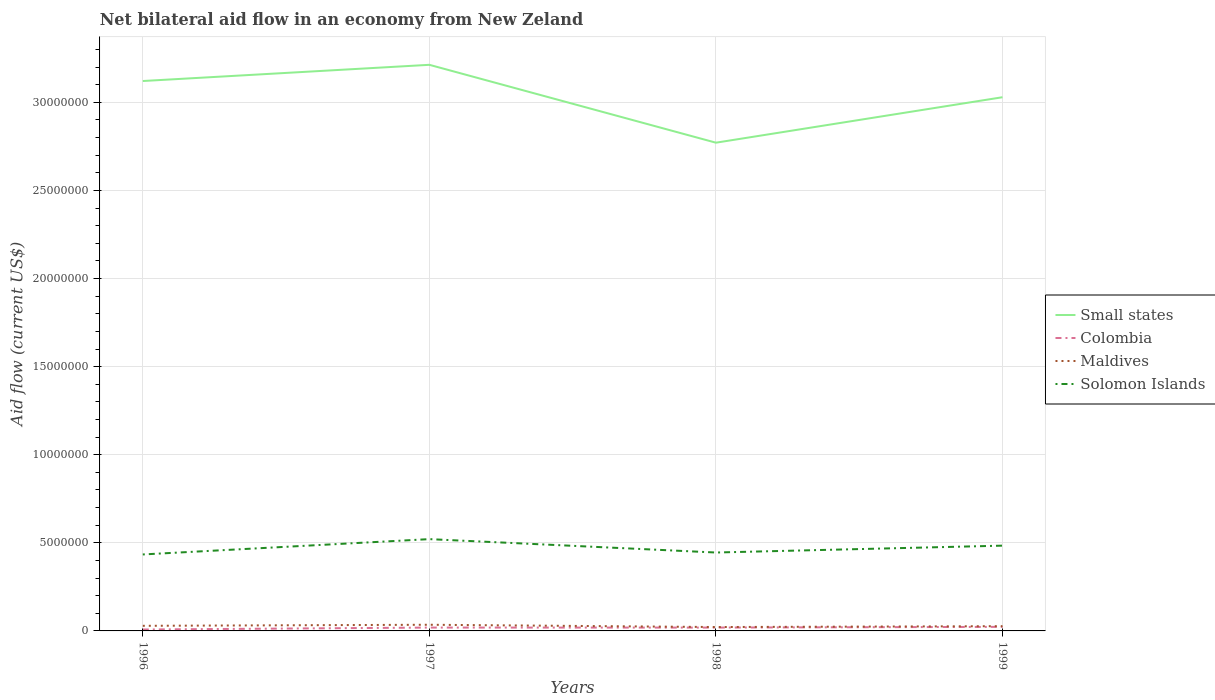Is the number of lines equal to the number of legend labels?
Ensure brevity in your answer.  Yes. Across all years, what is the maximum net bilateral aid flow in Solomon Islands?
Provide a short and direct response. 4.34e+06. What is the total net bilateral aid flow in Solomon Islands in the graph?
Your response must be concise. -8.70e+05. What is the difference between the highest and the lowest net bilateral aid flow in Solomon Islands?
Your answer should be very brief. 2. How many lines are there?
Offer a terse response. 4. How many years are there in the graph?
Your answer should be very brief. 4. What is the difference between two consecutive major ticks on the Y-axis?
Make the answer very short. 5.00e+06. Does the graph contain any zero values?
Your answer should be very brief. No. Where does the legend appear in the graph?
Provide a short and direct response. Center right. How many legend labels are there?
Your answer should be very brief. 4. How are the legend labels stacked?
Provide a succinct answer. Vertical. What is the title of the graph?
Your answer should be compact. Net bilateral aid flow in an economy from New Zeland. What is the label or title of the X-axis?
Your answer should be compact. Years. What is the Aid flow (current US$) of Small states in 1996?
Give a very brief answer. 3.12e+07. What is the Aid flow (current US$) in Colombia in 1996?
Give a very brief answer. 8.00e+04. What is the Aid flow (current US$) of Maldives in 1996?
Your answer should be compact. 2.90e+05. What is the Aid flow (current US$) of Solomon Islands in 1996?
Your response must be concise. 4.34e+06. What is the Aid flow (current US$) in Small states in 1997?
Your answer should be compact. 3.21e+07. What is the Aid flow (current US$) of Solomon Islands in 1997?
Make the answer very short. 5.21e+06. What is the Aid flow (current US$) of Small states in 1998?
Your answer should be compact. 2.77e+07. What is the Aid flow (current US$) of Colombia in 1998?
Give a very brief answer. 1.90e+05. What is the Aid flow (current US$) in Solomon Islands in 1998?
Make the answer very short. 4.45e+06. What is the Aid flow (current US$) in Small states in 1999?
Offer a terse response. 3.03e+07. What is the Aid flow (current US$) in Colombia in 1999?
Offer a terse response. 2.30e+05. What is the Aid flow (current US$) of Maldives in 1999?
Keep it short and to the point. 2.70e+05. What is the Aid flow (current US$) of Solomon Islands in 1999?
Your response must be concise. 4.84e+06. Across all years, what is the maximum Aid flow (current US$) of Small states?
Your response must be concise. 3.21e+07. Across all years, what is the maximum Aid flow (current US$) of Colombia?
Make the answer very short. 2.30e+05. Across all years, what is the maximum Aid flow (current US$) in Maldives?
Provide a succinct answer. 3.50e+05. Across all years, what is the maximum Aid flow (current US$) in Solomon Islands?
Offer a very short reply. 5.21e+06. Across all years, what is the minimum Aid flow (current US$) in Small states?
Offer a terse response. 2.77e+07. Across all years, what is the minimum Aid flow (current US$) in Maldives?
Offer a terse response. 2.20e+05. Across all years, what is the minimum Aid flow (current US$) of Solomon Islands?
Keep it short and to the point. 4.34e+06. What is the total Aid flow (current US$) in Small states in the graph?
Provide a short and direct response. 1.21e+08. What is the total Aid flow (current US$) of Colombia in the graph?
Give a very brief answer. 6.90e+05. What is the total Aid flow (current US$) of Maldives in the graph?
Provide a succinct answer. 1.13e+06. What is the total Aid flow (current US$) of Solomon Islands in the graph?
Keep it short and to the point. 1.88e+07. What is the difference between the Aid flow (current US$) in Small states in 1996 and that in 1997?
Give a very brief answer. -9.20e+05. What is the difference between the Aid flow (current US$) of Colombia in 1996 and that in 1997?
Your answer should be compact. -1.10e+05. What is the difference between the Aid flow (current US$) in Solomon Islands in 1996 and that in 1997?
Your answer should be very brief. -8.70e+05. What is the difference between the Aid flow (current US$) in Small states in 1996 and that in 1998?
Offer a terse response. 3.50e+06. What is the difference between the Aid flow (current US$) in Maldives in 1996 and that in 1998?
Provide a short and direct response. 7.00e+04. What is the difference between the Aid flow (current US$) of Small states in 1996 and that in 1999?
Keep it short and to the point. 9.20e+05. What is the difference between the Aid flow (current US$) in Maldives in 1996 and that in 1999?
Make the answer very short. 2.00e+04. What is the difference between the Aid flow (current US$) of Solomon Islands in 1996 and that in 1999?
Keep it short and to the point. -5.00e+05. What is the difference between the Aid flow (current US$) of Small states in 1997 and that in 1998?
Your answer should be compact. 4.42e+06. What is the difference between the Aid flow (current US$) in Colombia in 1997 and that in 1998?
Your response must be concise. 0. What is the difference between the Aid flow (current US$) of Maldives in 1997 and that in 1998?
Your answer should be very brief. 1.30e+05. What is the difference between the Aid flow (current US$) in Solomon Islands in 1997 and that in 1998?
Offer a terse response. 7.60e+05. What is the difference between the Aid flow (current US$) of Small states in 1997 and that in 1999?
Your answer should be compact. 1.84e+06. What is the difference between the Aid flow (current US$) in Small states in 1998 and that in 1999?
Offer a very short reply. -2.58e+06. What is the difference between the Aid flow (current US$) of Solomon Islands in 1998 and that in 1999?
Provide a succinct answer. -3.90e+05. What is the difference between the Aid flow (current US$) in Small states in 1996 and the Aid flow (current US$) in Colombia in 1997?
Ensure brevity in your answer.  3.10e+07. What is the difference between the Aid flow (current US$) of Small states in 1996 and the Aid flow (current US$) of Maldives in 1997?
Give a very brief answer. 3.09e+07. What is the difference between the Aid flow (current US$) in Small states in 1996 and the Aid flow (current US$) in Solomon Islands in 1997?
Make the answer very short. 2.60e+07. What is the difference between the Aid flow (current US$) in Colombia in 1996 and the Aid flow (current US$) in Maldives in 1997?
Give a very brief answer. -2.70e+05. What is the difference between the Aid flow (current US$) in Colombia in 1996 and the Aid flow (current US$) in Solomon Islands in 1997?
Keep it short and to the point. -5.13e+06. What is the difference between the Aid flow (current US$) in Maldives in 1996 and the Aid flow (current US$) in Solomon Islands in 1997?
Offer a terse response. -4.92e+06. What is the difference between the Aid flow (current US$) in Small states in 1996 and the Aid flow (current US$) in Colombia in 1998?
Offer a very short reply. 3.10e+07. What is the difference between the Aid flow (current US$) in Small states in 1996 and the Aid flow (current US$) in Maldives in 1998?
Ensure brevity in your answer.  3.10e+07. What is the difference between the Aid flow (current US$) in Small states in 1996 and the Aid flow (current US$) in Solomon Islands in 1998?
Keep it short and to the point. 2.68e+07. What is the difference between the Aid flow (current US$) of Colombia in 1996 and the Aid flow (current US$) of Maldives in 1998?
Ensure brevity in your answer.  -1.40e+05. What is the difference between the Aid flow (current US$) in Colombia in 1996 and the Aid flow (current US$) in Solomon Islands in 1998?
Offer a very short reply. -4.37e+06. What is the difference between the Aid flow (current US$) in Maldives in 1996 and the Aid flow (current US$) in Solomon Islands in 1998?
Offer a very short reply. -4.16e+06. What is the difference between the Aid flow (current US$) of Small states in 1996 and the Aid flow (current US$) of Colombia in 1999?
Your answer should be compact. 3.10e+07. What is the difference between the Aid flow (current US$) in Small states in 1996 and the Aid flow (current US$) in Maldives in 1999?
Offer a very short reply. 3.09e+07. What is the difference between the Aid flow (current US$) of Small states in 1996 and the Aid flow (current US$) of Solomon Islands in 1999?
Provide a short and direct response. 2.64e+07. What is the difference between the Aid flow (current US$) of Colombia in 1996 and the Aid flow (current US$) of Solomon Islands in 1999?
Provide a short and direct response. -4.76e+06. What is the difference between the Aid flow (current US$) in Maldives in 1996 and the Aid flow (current US$) in Solomon Islands in 1999?
Offer a terse response. -4.55e+06. What is the difference between the Aid flow (current US$) of Small states in 1997 and the Aid flow (current US$) of Colombia in 1998?
Offer a terse response. 3.19e+07. What is the difference between the Aid flow (current US$) of Small states in 1997 and the Aid flow (current US$) of Maldives in 1998?
Offer a terse response. 3.19e+07. What is the difference between the Aid flow (current US$) of Small states in 1997 and the Aid flow (current US$) of Solomon Islands in 1998?
Offer a very short reply. 2.77e+07. What is the difference between the Aid flow (current US$) of Colombia in 1997 and the Aid flow (current US$) of Maldives in 1998?
Keep it short and to the point. -3.00e+04. What is the difference between the Aid flow (current US$) of Colombia in 1997 and the Aid flow (current US$) of Solomon Islands in 1998?
Make the answer very short. -4.26e+06. What is the difference between the Aid flow (current US$) in Maldives in 1997 and the Aid flow (current US$) in Solomon Islands in 1998?
Make the answer very short. -4.10e+06. What is the difference between the Aid flow (current US$) in Small states in 1997 and the Aid flow (current US$) in Colombia in 1999?
Offer a terse response. 3.19e+07. What is the difference between the Aid flow (current US$) in Small states in 1997 and the Aid flow (current US$) in Maldives in 1999?
Make the answer very short. 3.19e+07. What is the difference between the Aid flow (current US$) of Small states in 1997 and the Aid flow (current US$) of Solomon Islands in 1999?
Provide a short and direct response. 2.73e+07. What is the difference between the Aid flow (current US$) of Colombia in 1997 and the Aid flow (current US$) of Maldives in 1999?
Ensure brevity in your answer.  -8.00e+04. What is the difference between the Aid flow (current US$) in Colombia in 1997 and the Aid flow (current US$) in Solomon Islands in 1999?
Provide a short and direct response. -4.65e+06. What is the difference between the Aid flow (current US$) of Maldives in 1997 and the Aid flow (current US$) of Solomon Islands in 1999?
Offer a terse response. -4.49e+06. What is the difference between the Aid flow (current US$) in Small states in 1998 and the Aid flow (current US$) in Colombia in 1999?
Give a very brief answer. 2.75e+07. What is the difference between the Aid flow (current US$) of Small states in 1998 and the Aid flow (current US$) of Maldives in 1999?
Your answer should be compact. 2.74e+07. What is the difference between the Aid flow (current US$) of Small states in 1998 and the Aid flow (current US$) of Solomon Islands in 1999?
Offer a very short reply. 2.29e+07. What is the difference between the Aid flow (current US$) in Colombia in 1998 and the Aid flow (current US$) in Maldives in 1999?
Your answer should be very brief. -8.00e+04. What is the difference between the Aid flow (current US$) of Colombia in 1998 and the Aid flow (current US$) of Solomon Islands in 1999?
Provide a short and direct response. -4.65e+06. What is the difference between the Aid flow (current US$) of Maldives in 1998 and the Aid flow (current US$) of Solomon Islands in 1999?
Provide a succinct answer. -4.62e+06. What is the average Aid flow (current US$) of Small states per year?
Give a very brief answer. 3.03e+07. What is the average Aid flow (current US$) of Colombia per year?
Provide a succinct answer. 1.72e+05. What is the average Aid flow (current US$) in Maldives per year?
Keep it short and to the point. 2.82e+05. What is the average Aid flow (current US$) of Solomon Islands per year?
Ensure brevity in your answer.  4.71e+06. In the year 1996, what is the difference between the Aid flow (current US$) in Small states and Aid flow (current US$) in Colombia?
Your answer should be compact. 3.11e+07. In the year 1996, what is the difference between the Aid flow (current US$) in Small states and Aid flow (current US$) in Maldives?
Your answer should be very brief. 3.09e+07. In the year 1996, what is the difference between the Aid flow (current US$) in Small states and Aid flow (current US$) in Solomon Islands?
Ensure brevity in your answer.  2.69e+07. In the year 1996, what is the difference between the Aid flow (current US$) in Colombia and Aid flow (current US$) in Maldives?
Give a very brief answer. -2.10e+05. In the year 1996, what is the difference between the Aid flow (current US$) in Colombia and Aid flow (current US$) in Solomon Islands?
Offer a very short reply. -4.26e+06. In the year 1996, what is the difference between the Aid flow (current US$) of Maldives and Aid flow (current US$) of Solomon Islands?
Offer a very short reply. -4.05e+06. In the year 1997, what is the difference between the Aid flow (current US$) of Small states and Aid flow (current US$) of Colombia?
Give a very brief answer. 3.19e+07. In the year 1997, what is the difference between the Aid flow (current US$) of Small states and Aid flow (current US$) of Maldives?
Ensure brevity in your answer.  3.18e+07. In the year 1997, what is the difference between the Aid flow (current US$) of Small states and Aid flow (current US$) of Solomon Islands?
Your answer should be compact. 2.69e+07. In the year 1997, what is the difference between the Aid flow (current US$) of Colombia and Aid flow (current US$) of Solomon Islands?
Keep it short and to the point. -5.02e+06. In the year 1997, what is the difference between the Aid flow (current US$) in Maldives and Aid flow (current US$) in Solomon Islands?
Provide a short and direct response. -4.86e+06. In the year 1998, what is the difference between the Aid flow (current US$) of Small states and Aid flow (current US$) of Colombia?
Provide a short and direct response. 2.75e+07. In the year 1998, what is the difference between the Aid flow (current US$) of Small states and Aid flow (current US$) of Maldives?
Provide a succinct answer. 2.75e+07. In the year 1998, what is the difference between the Aid flow (current US$) of Small states and Aid flow (current US$) of Solomon Islands?
Make the answer very short. 2.33e+07. In the year 1998, what is the difference between the Aid flow (current US$) of Colombia and Aid flow (current US$) of Maldives?
Offer a terse response. -3.00e+04. In the year 1998, what is the difference between the Aid flow (current US$) in Colombia and Aid flow (current US$) in Solomon Islands?
Your answer should be very brief. -4.26e+06. In the year 1998, what is the difference between the Aid flow (current US$) of Maldives and Aid flow (current US$) of Solomon Islands?
Offer a very short reply. -4.23e+06. In the year 1999, what is the difference between the Aid flow (current US$) in Small states and Aid flow (current US$) in Colombia?
Give a very brief answer. 3.01e+07. In the year 1999, what is the difference between the Aid flow (current US$) in Small states and Aid flow (current US$) in Maldives?
Keep it short and to the point. 3.00e+07. In the year 1999, what is the difference between the Aid flow (current US$) in Small states and Aid flow (current US$) in Solomon Islands?
Offer a very short reply. 2.54e+07. In the year 1999, what is the difference between the Aid flow (current US$) of Colombia and Aid flow (current US$) of Solomon Islands?
Offer a very short reply. -4.61e+06. In the year 1999, what is the difference between the Aid flow (current US$) of Maldives and Aid flow (current US$) of Solomon Islands?
Give a very brief answer. -4.57e+06. What is the ratio of the Aid flow (current US$) in Small states in 1996 to that in 1997?
Ensure brevity in your answer.  0.97. What is the ratio of the Aid flow (current US$) of Colombia in 1996 to that in 1997?
Make the answer very short. 0.42. What is the ratio of the Aid flow (current US$) of Maldives in 1996 to that in 1997?
Offer a very short reply. 0.83. What is the ratio of the Aid flow (current US$) in Solomon Islands in 1996 to that in 1997?
Ensure brevity in your answer.  0.83. What is the ratio of the Aid flow (current US$) of Small states in 1996 to that in 1998?
Provide a short and direct response. 1.13. What is the ratio of the Aid flow (current US$) of Colombia in 1996 to that in 1998?
Provide a short and direct response. 0.42. What is the ratio of the Aid flow (current US$) in Maldives in 1996 to that in 1998?
Keep it short and to the point. 1.32. What is the ratio of the Aid flow (current US$) of Solomon Islands in 1996 to that in 1998?
Give a very brief answer. 0.98. What is the ratio of the Aid flow (current US$) of Small states in 1996 to that in 1999?
Your answer should be very brief. 1.03. What is the ratio of the Aid flow (current US$) in Colombia in 1996 to that in 1999?
Ensure brevity in your answer.  0.35. What is the ratio of the Aid flow (current US$) in Maldives in 1996 to that in 1999?
Offer a very short reply. 1.07. What is the ratio of the Aid flow (current US$) of Solomon Islands in 1996 to that in 1999?
Your answer should be compact. 0.9. What is the ratio of the Aid flow (current US$) in Small states in 1997 to that in 1998?
Make the answer very short. 1.16. What is the ratio of the Aid flow (current US$) of Colombia in 1997 to that in 1998?
Make the answer very short. 1. What is the ratio of the Aid flow (current US$) of Maldives in 1997 to that in 1998?
Your response must be concise. 1.59. What is the ratio of the Aid flow (current US$) in Solomon Islands in 1997 to that in 1998?
Your answer should be very brief. 1.17. What is the ratio of the Aid flow (current US$) in Small states in 1997 to that in 1999?
Give a very brief answer. 1.06. What is the ratio of the Aid flow (current US$) of Colombia in 1997 to that in 1999?
Keep it short and to the point. 0.83. What is the ratio of the Aid flow (current US$) of Maldives in 1997 to that in 1999?
Offer a terse response. 1.3. What is the ratio of the Aid flow (current US$) in Solomon Islands in 1997 to that in 1999?
Your answer should be very brief. 1.08. What is the ratio of the Aid flow (current US$) in Small states in 1998 to that in 1999?
Provide a succinct answer. 0.91. What is the ratio of the Aid flow (current US$) in Colombia in 1998 to that in 1999?
Your answer should be very brief. 0.83. What is the ratio of the Aid flow (current US$) in Maldives in 1998 to that in 1999?
Your answer should be very brief. 0.81. What is the ratio of the Aid flow (current US$) of Solomon Islands in 1998 to that in 1999?
Provide a succinct answer. 0.92. What is the difference between the highest and the second highest Aid flow (current US$) in Small states?
Your answer should be compact. 9.20e+05. What is the difference between the highest and the second highest Aid flow (current US$) in Colombia?
Ensure brevity in your answer.  4.00e+04. What is the difference between the highest and the second highest Aid flow (current US$) of Maldives?
Your response must be concise. 6.00e+04. What is the difference between the highest and the second highest Aid flow (current US$) in Solomon Islands?
Give a very brief answer. 3.70e+05. What is the difference between the highest and the lowest Aid flow (current US$) in Small states?
Give a very brief answer. 4.42e+06. What is the difference between the highest and the lowest Aid flow (current US$) in Colombia?
Make the answer very short. 1.50e+05. What is the difference between the highest and the lowest Aid flow (current US$) of Solomon Islands?
Give a very brief answer. 8.70e+05. 